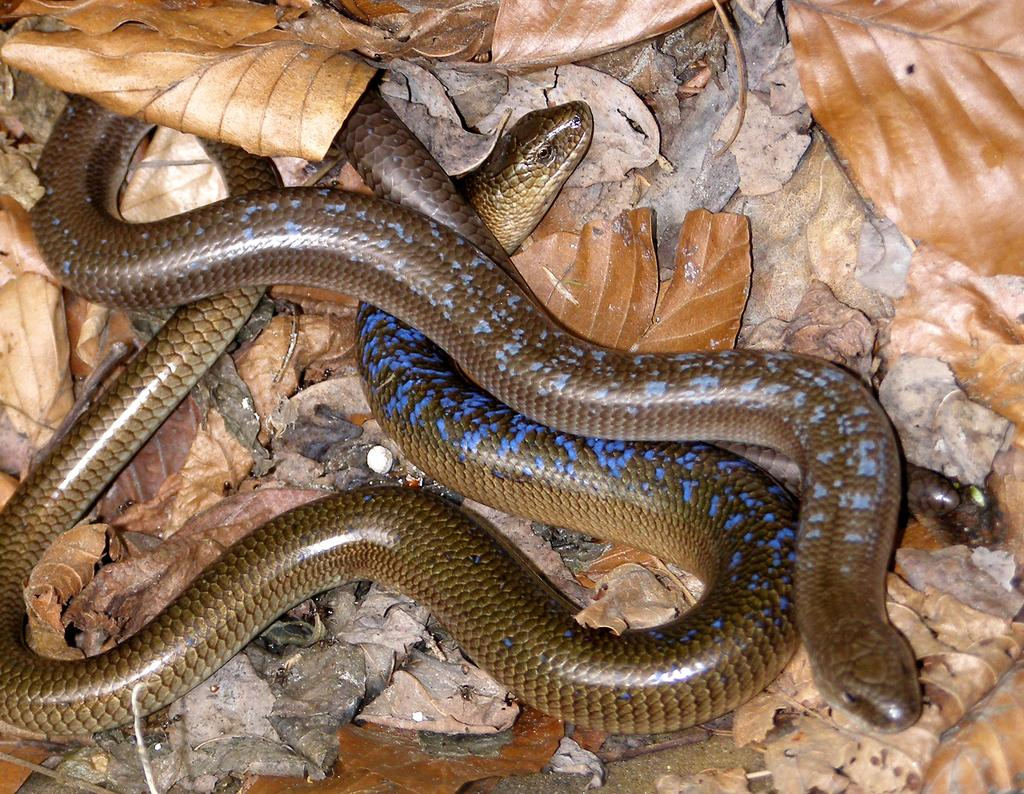What type of animals can be seen on the ground in the image? There are snakes on the ground in the image. What can be seen in the background of the image? There are dried leaves visible in the background of the image. How many aunts are sitting in the plane in the image? There is no plane or aunt present in the image; it features snakes on the ground and dried leaves in the background. 